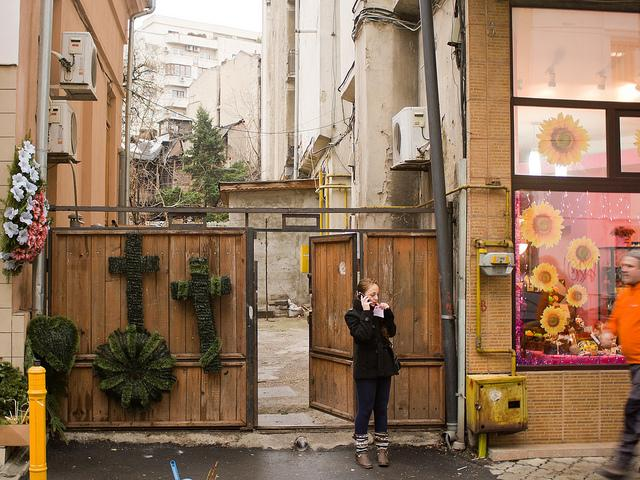What shape are two of the grass wreaths fashioned into? cross 